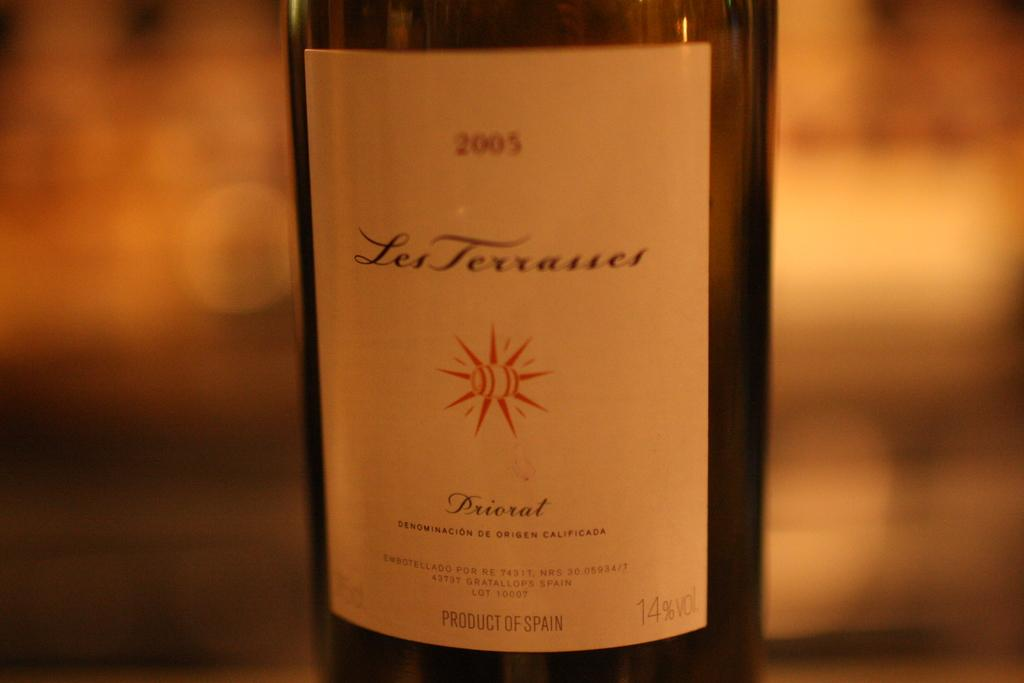Provide a one-sentence caption for the provided image. The 2005 bottle of wine is a product of Spain. 